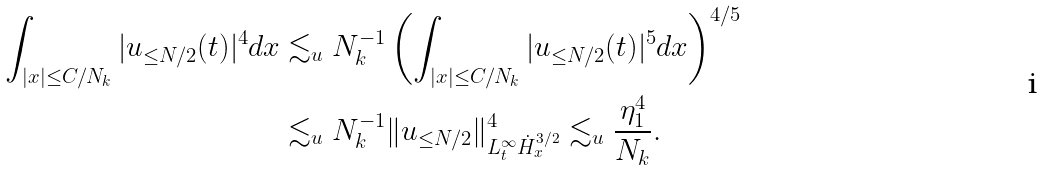<formula> <loc_0><loc_0><loc_500><loc_500>\int _ { | x | \leq C / N _ { k } } | u _ { \leq N / 2 } ( t ) | ^ { 4 } d x & \lesssim _ { u } N _ { k } ^ { - 1 } \left ( \int _ { | x | \leq C / N _ { k } } | u _ { \leq N / 2 } ( t ) | ^ { 5 } d x \right ) ^ { 4 / 5 } \\ & \lesssim _ { u } N _ { k } ^ { - 1 } \| u _ { \leq N / 2 } \| _ { L _ { t } ^ { \infty } \dot { H } _ { x } ^ { 3 / 2 } } ^ { 4 } \lesssim _ { u } \frac { \eta _ { 1 } ^ { 4 } } { N _ { k } } .</formula> 